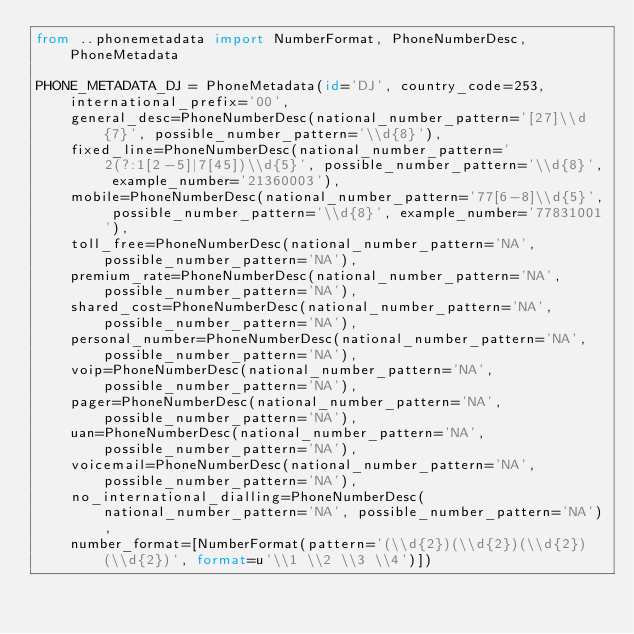<code> <loc_0><loc_0><loc_500><loc_500><_Python_>from ..phonemetadata import NumberFormat, PhoneNumberDesc, PhoneMetadata

PHONE_METADATA_DJ = PhoneMetadata(id='DJ', country_code=253, international_prefix='00',
    general_desc=PhoneNumberDesc(national_number_pattern='[27]\\d{7}', possible_number_pattern='\\d{8}'),
    fixed_line=PhoneNumberDesc(national_number_pattern='2(?:1[2-5]|7[45])\\d{5}', possible_number_pattern='\\d{8}', example_number='21360003'),
    mobile=PhoneNumberDesc(national_number_pattern='77[6-8]\\d{5}', possible_number_pattern='\\d{8}', example_number='77831001'),
    toll_free=PhoneNumberDesc(national_number_pattern='NA', possible_number_pattern='NA'),
    premium_rate=PhoneNumberDesc(national_number_pattern='NA', possible_number_pattern='NA'),
    shared_cost=PhoneNumberDesc(national_number_pattern='NA', possible_number_pattern='NA'),
    personal_number=PhoneNumberDesc(national_number_pattern='NA', possible_number_pattern='NA'),
    voip=PhoneNumberDesc(national_number_pattern='NA', possible_number_pattern='NA'),
    pager=PhoneNumberDesc(national_number_pattern='NA', possible_number_pattern='NA'),
    uan=PhoneNumberDesc(national_number_pattern='NA', possible_number_pattern='NA'),
    voicemail=PhoneNumberDesc(national_number_pattern='NA', possible_number_pattern='NA'),
    no_international_dialling=PhoneNumberDesc(national_number_pattern='NA', possible_number_pattern='NA'),
    number_format=[NumberFormat(pattern='(\\d{2})(\\d{2})(\\d{2})(\\d{2})', format=u'\\1 \\2 \\3 \\4')])
</code> 